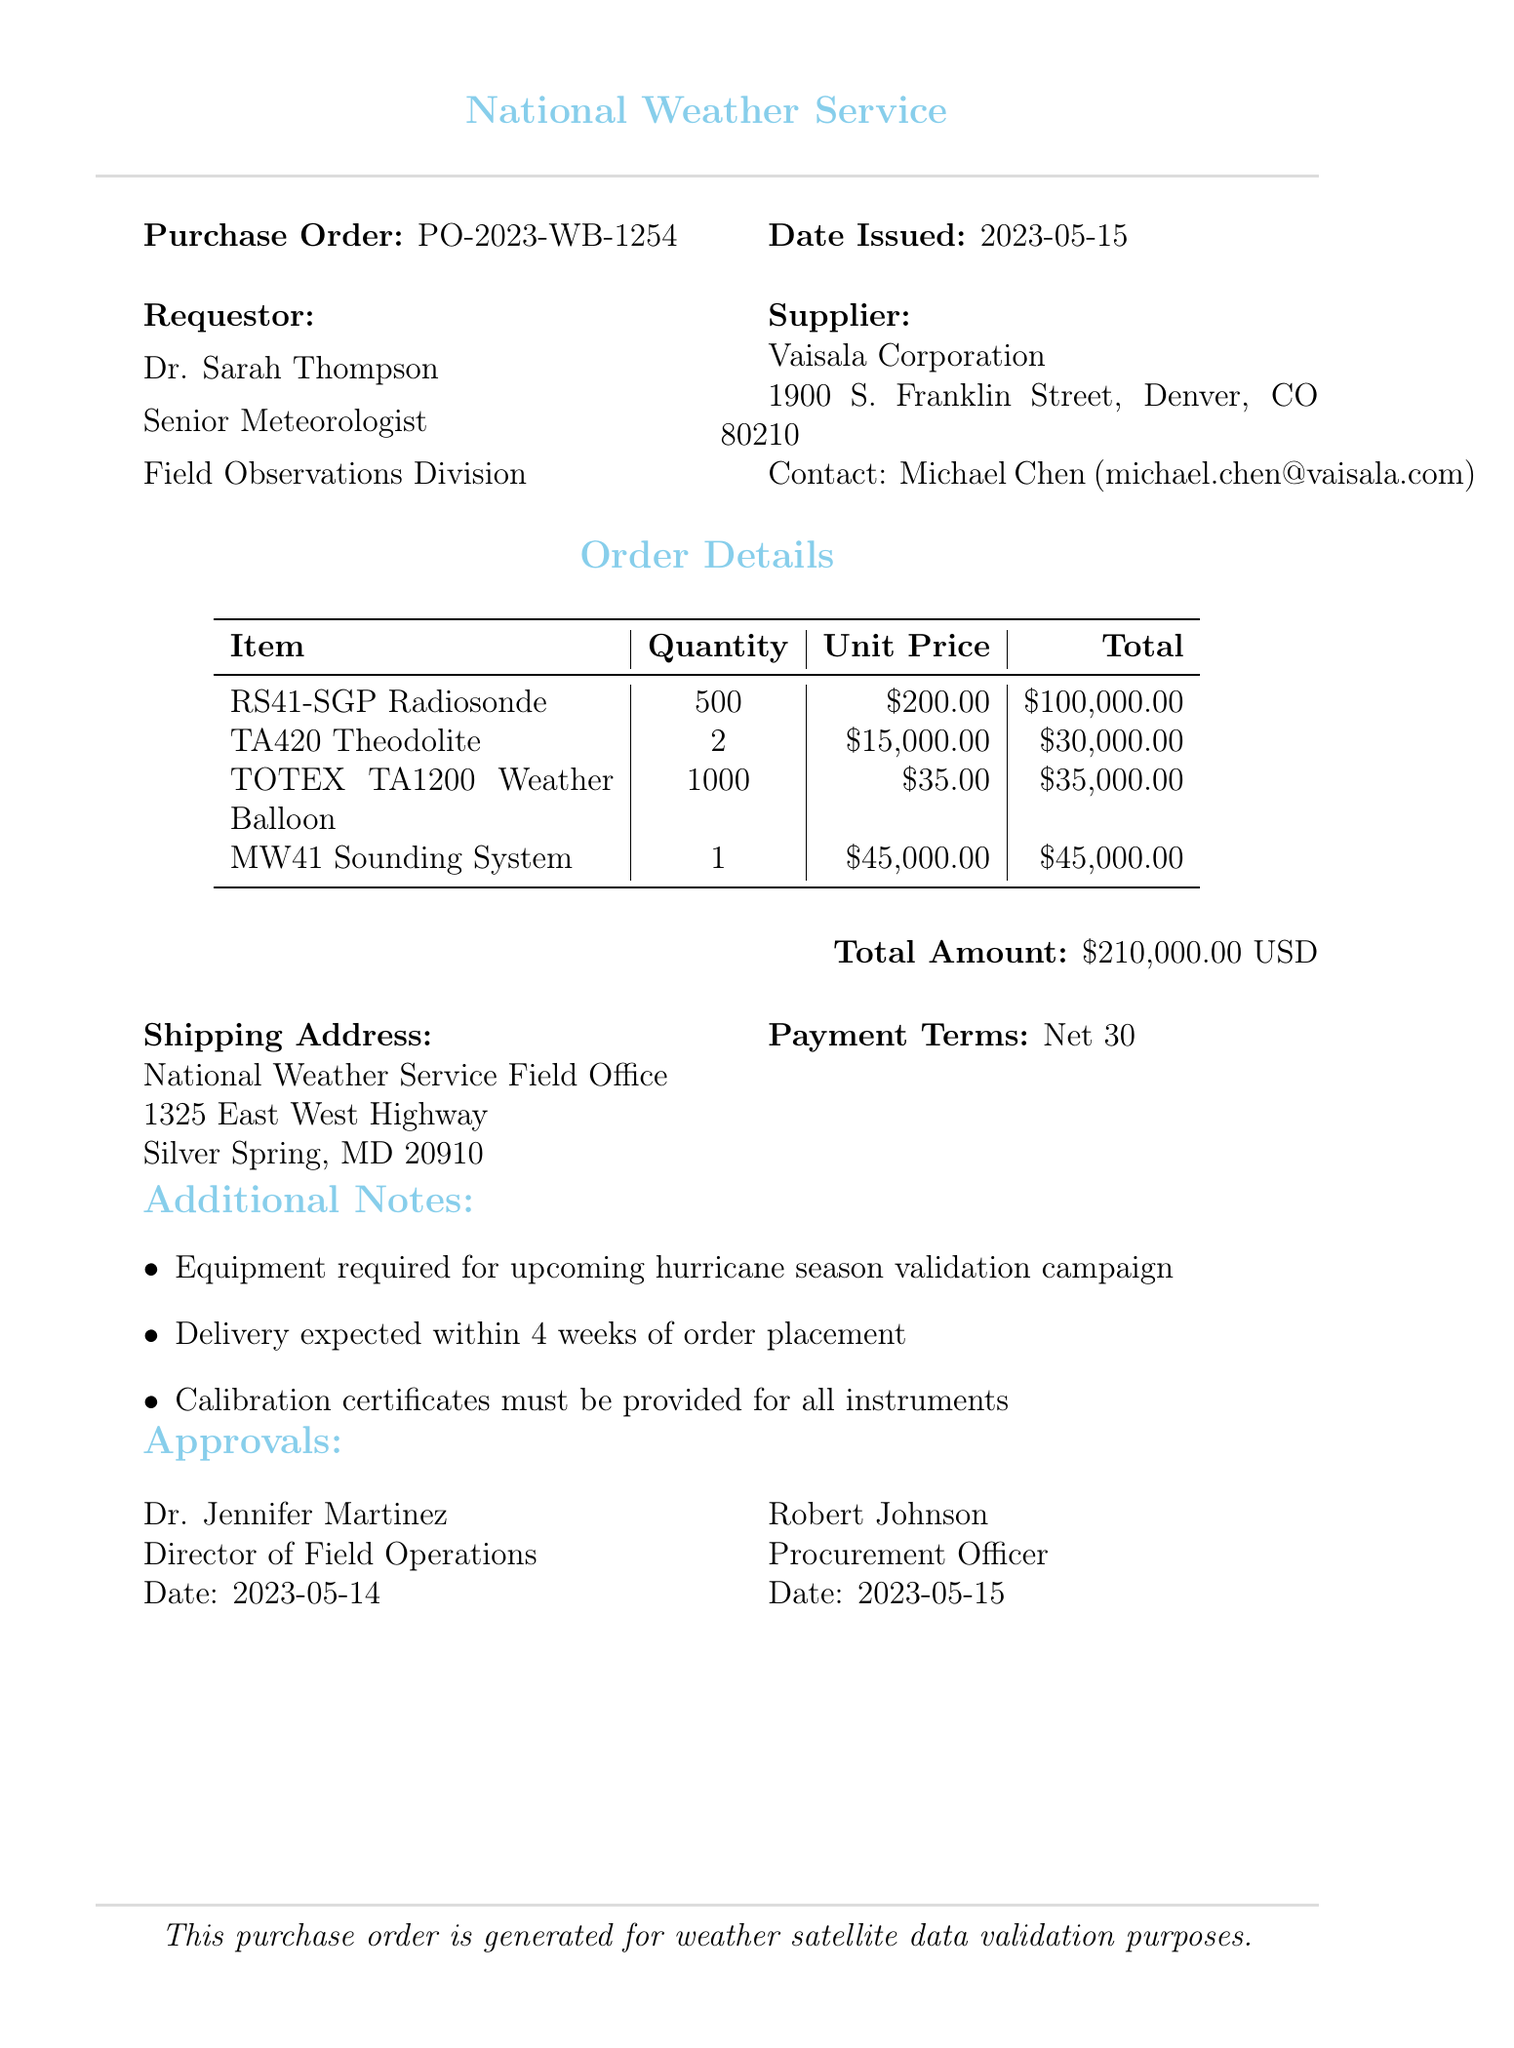What is the purchase order number? The purchase order number is listed at the beginning of the document, which identifies this specific transaction.
Answer: PO-2023-WB-1254 Who is the requestor's title? The requestor's title is provided in the document under the requestor section.
Answer: Senior Meteorologist What is the total amount of the purchase order? The total amount is calculated by summing all the item prices listed in the document.
Answer: 210000.00 How many RS41-SGP Radiosondes are being ordered? The quantity of RS41-SGP Radiosondes is explicitly mentioned in the items list within the order details.
Answer: 500 What is the expected delivery time for the order? The delivery timeline is noted in the additional notes section of the document, providing insights into when the items are expected to arrive.
Answer: 4 weeks Who approved the order first? The approvals section provides a list of names along with their titles and dates; it indicates who approved the order and when.
Answer: Dr. Jennifer Martinez What is the unit price of the MW41 Sounding System? The unit price is specified in the order details under the item's pricing information.
Answer: 45000.00 Which organization is the supplier? The supplier's organization is stated clearly in the supplier section of the document.
Answer: Vaisala Corporation What type of equipment is required for? The additional notes specify the purpose of the equipment ordered, linking it to a specific weather-related activity.
Answer: hurricane season validation campaign 